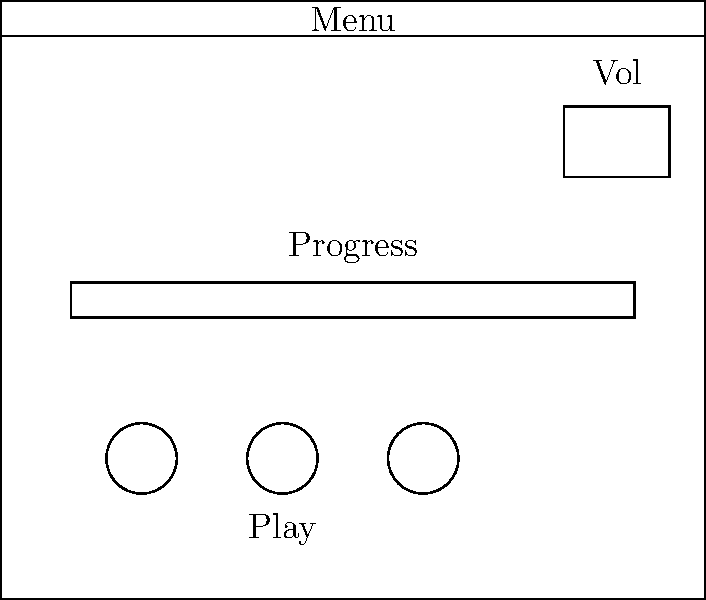As a programming student focusing on multimedia applications, you are tasked with designing a user interface layout for a media player application. Based on the given diagram, which essential component is missing from this basic media player interface that would allow users to select and manage their media content? Let's analyze the components present in the given media player interface:

1. Main window: Provides the overall container for the application.
2. Menu bar: Allows access to various application features and settings.
3. Play controls: Enable basic playback functionality (play, pause, stop).
4. Progress bar: Shows the current position in the media playback.
5. Volume control: Allows adjustment of audio output level.

However, a crucial component is missing from this layout. To allow users to select and manage their media content, the interface should include a playlist or media library view. This component would typically be placed in the main content area of the application window, allowing users to:

1. View their available media files
2. Select items for playback
3. Create and manage playlists
4. Sort and search their media collection

Without this component, users would have no way to choose which media to play or organize their content within the application. For a functional multimedia application, especially a media player, the ability to browse and select content is essential.
Answer: Playlist or media library view 